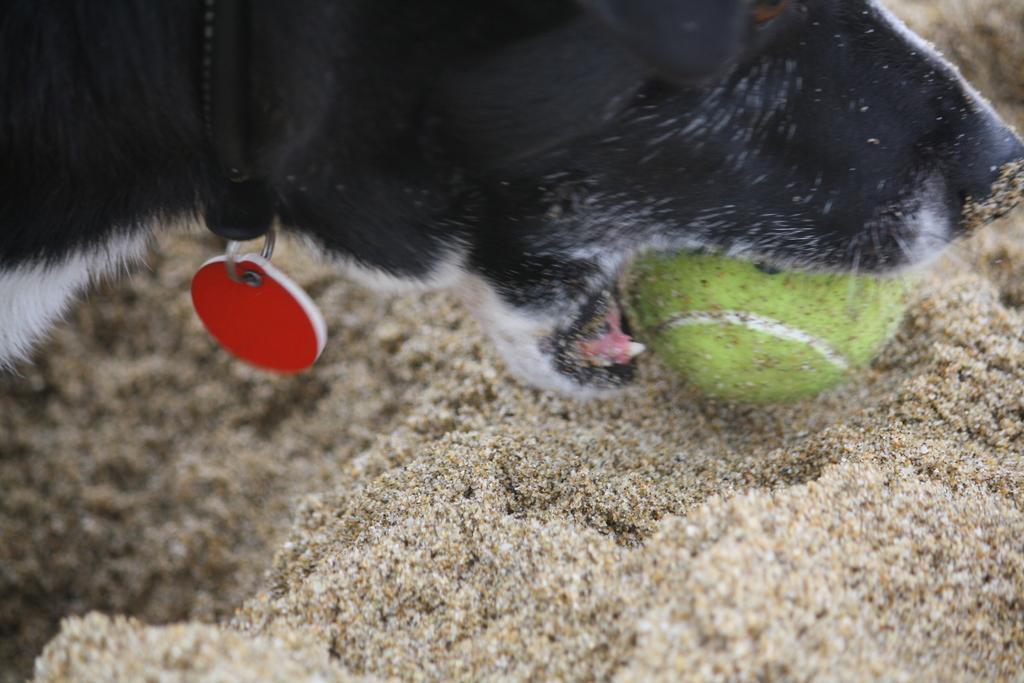Please provide a concise description of this image. In this image, we can see a black and white dog with belt and locket is trying to hold the ball with the help of mouth. Background we can see the sand. 